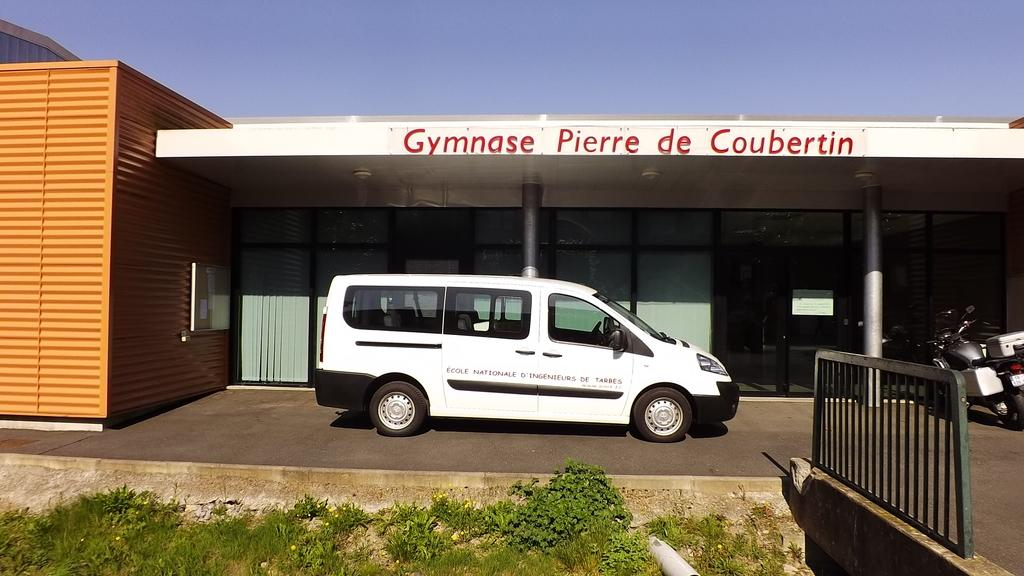Provide a one-sentence caption for the provided image. A white van sits in front of Gymnase Pierre de Coubertin. 